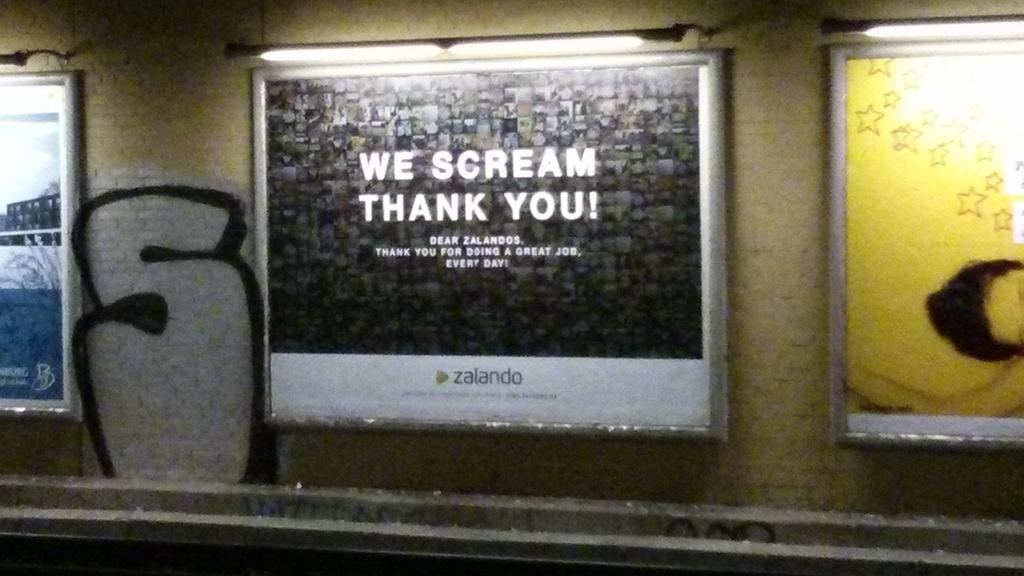What is present on the wall in the image? There are hoardings on the wall. What can be seen above the hoardings? There are lights above the hoardings. What type of vest is the woman wearing in the image? There is no woman present in the image, so it is not possible to determine what type of vest she might be wearing. 